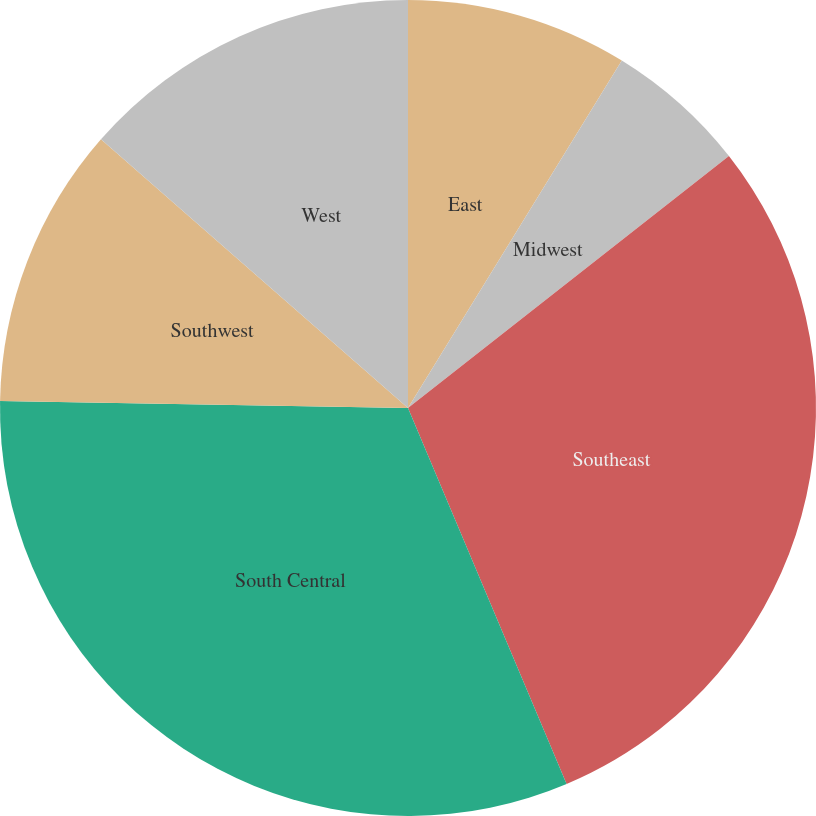Convert chart to OTSL. <chart><loc_0><loc_0><loc_500><loc_500><pie_chart><fcel>East<fcel>Midwest<fcel>Southeast<fcel>South Central<fcel>Southwest<fcel>West<nl><fcel>8.78%<fcel>5.63%<fcel>29.24%<fcel>31.63%<fcel>11.17%<fcel>13.56%<nl></chart> 